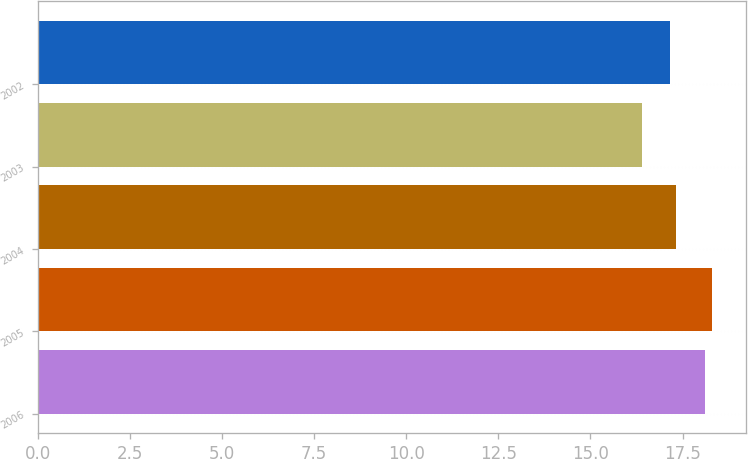<chart> <loc_0><loc_0><loc_500><loc_500><bar_chart><fcel>2006<fcel>2005<fcel>2004<fcel>2003<fcel>2002<nl><fcel>18.12<fcel>18.3<fcel>17.33<fcel>16.41<fcel>17.15<nl></chart> 